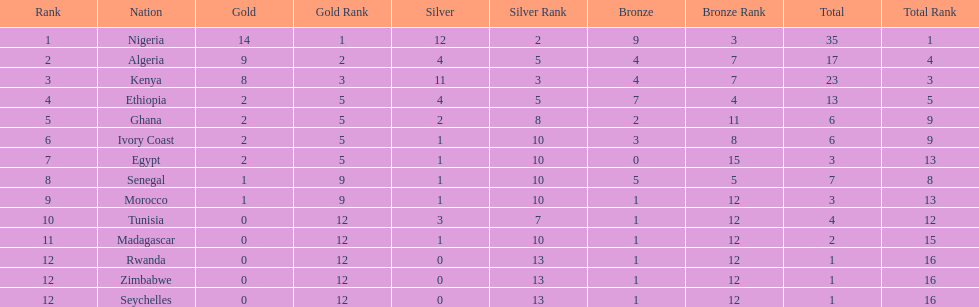How many medals did senegal win? 7. 